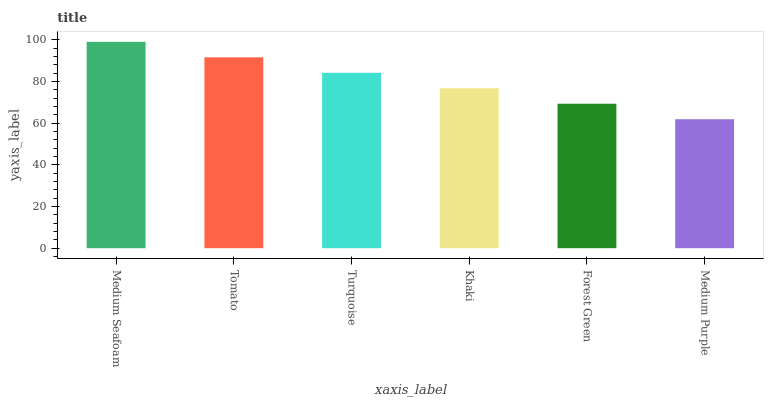Is Medium Purple the minimum?
Answer yes or no. Yes. Is Medium Seafoam the maximum?
Answer yes or no. Yes. Is Tomato the minimum?
Answer yes or no. No. Is Tomato the maximum?
Answer yes or no. No. Is Medium Seafoam greater than Tomato?
Answer yes or no. Yes. Is Tomato less than Medium Seafoam?
Answer yes or no. Yes. Is Tomato greater than Medium Seafoam?
Answer yes or no. No. Is Medium Seafoam less than Tomato?
Answer yes or no. No. Is Turquoise the high median?
Answer yes or no. Yes. Is Khaki the low median?
Answer yes or no. Yes. Is Medium Purple the high median?
Answer yes or no. No. Is Medium Seafoam the low median?
Answer yes or no. No. 